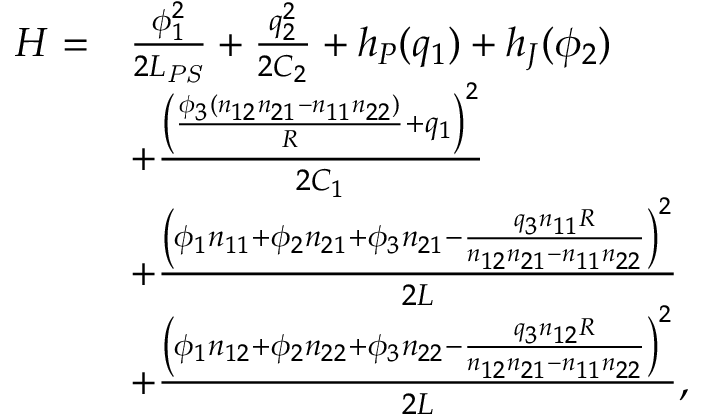<formula> <loc_0><loc_0><loc_500><loc_500>\begin{array} { r l } { H = } & { \frac { \phi _ { 1 } ^ { 2 } } { 2 L _ { P S } } + \frac { q _ { 2 } ^ { 2 } } { 2 C _ { 2 } } + h _ { P } ( q _ { 1 } ) + h _ { J } ( \phi _ { 2 } ) } \\ & { + \frac { { \left ( \frac { \phi _ { 3 } ( n _ { 1 2 } n _ { 2 1 } - n _ { 1 1 } n _ { 2 2 } ) } { R } + q _ { 1 } \right ) } ^ { 2 } } { 2 C _ { 1 } } } \\ & { + \frac { { \left ( \phi _ { 1 } n _ { 1 1 } + \phi _ { 2 } n _ { 2 1 } + \phi _ { 3 } n _ { 2 1 } - \frac { q _ { 3 } n _ { 1 1 } R } { n _ { 1 2 } n _ { 2 1 } - n _ { 1 1 } n _ { 2 2 } } \right ) } ^ { 2 } } { 2 L } } \\ & { + \frac { { \left ( \phi _ { 1 } n _ { 1 2 } + \phi _ { 2 } n _ { 2 2 } + \phi _ { 3 } n _ { 2 2 } - \frac { q _ { 3 } n _ { 1 2 } R } { n _ { 1 2 } n _ { 2 1 } - n _ { 1 1 } n _ { 2 2 } } \right ) } ^ { 2 } } { 2 L } , } \end{array}</formula> 